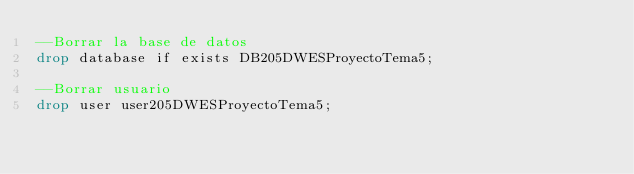<code> <loc_0><loc_0><loc_500><loc_500><_SQL_>--Borrar la base de datos
drop database if exists DB205DWESProyectoTema5;

--Borrar usuario
drop user user205DWESProyectoTema5;</code> 